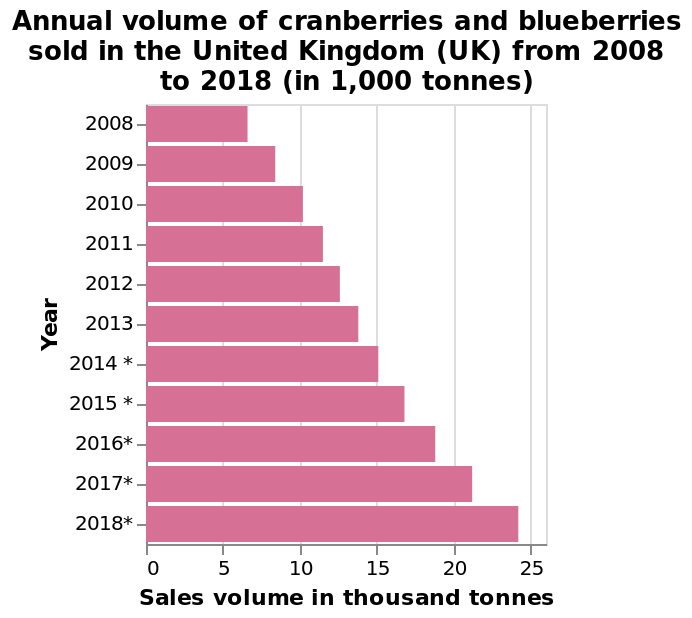<image>
Are cranberries and blueberries the only fruits included in the sales volume data? The description does not state if cranberries and blueberries are the only fruits included in the sales volume data. 